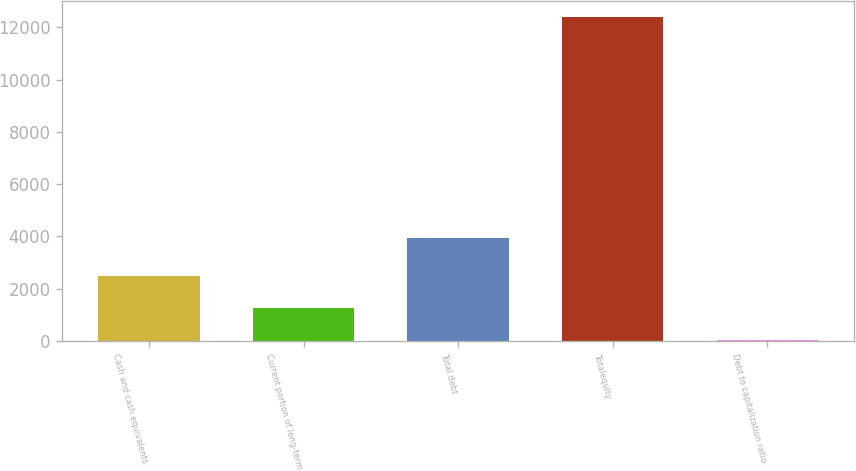Convert chart to OTSL. <chart><loc_0><loc_0><loc_500><loc_500><bar_chart><fcel>Cash and cash equivalents<fcel>Current portion of long-term<fcel>Total debt<fcel>Totalequity<fcel>Debt to capitalization ratio<nl><fcel>2497.56<fcel>1260.88<fcel>3955<fcel>12391<fcel>24.2<nl></chart> 